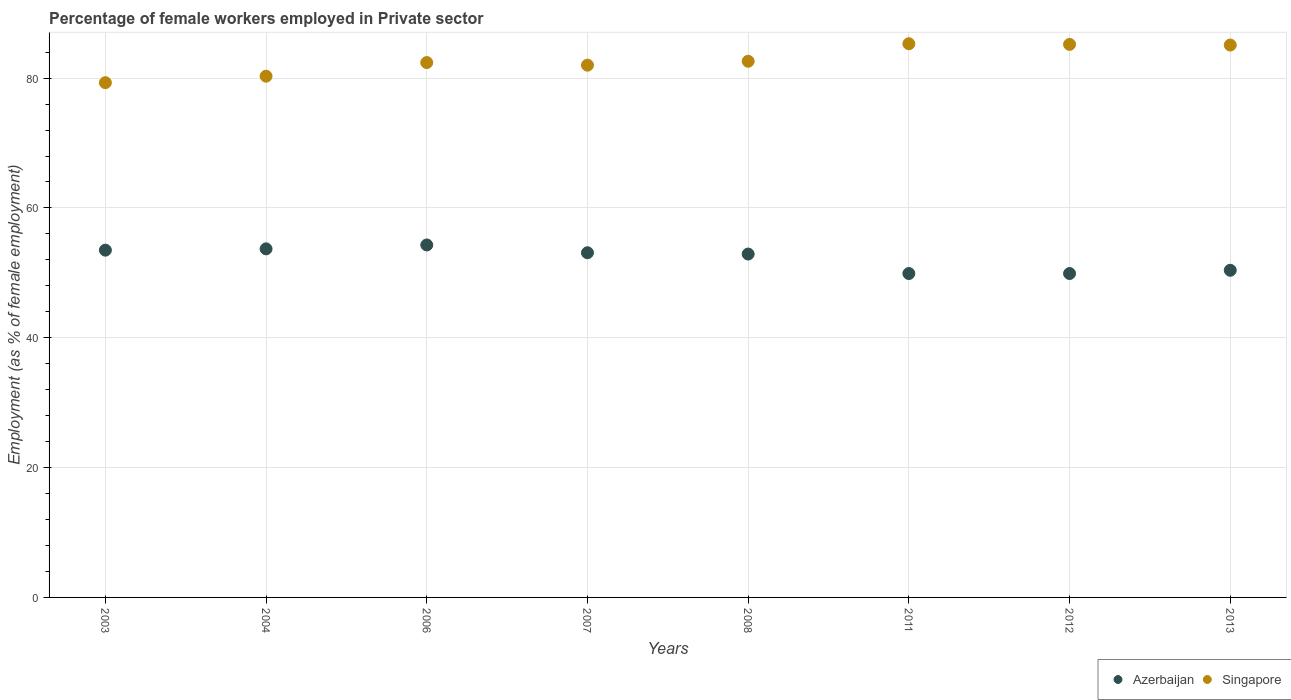How many different coloured dotlines are there?
Your response must be concise. 2. What is the percentage of females employed in Private sector in Singapore in 2007?
Make the answer very short. 82. Across all years, what is the maximum percentage of females employed in Private sector in Azerbaijan?
Give a very brief answer. 54.3. Across all years, what is the minimum percentage of females employed in Private sector in Singapore?
Your answer should be compact. 79.3. What is the total percentage of females employed in Private sector in Azerbaijan in the graph?
Your answer should be compact. 417.7. What is the difference between the percentage of females employed in Private sector in Azerbaijan in 2003 and that in 2006?
Keep it short and to the point. -0.8. What is the difference between the percentage of females employed in Private sector in Azerbaijan in 2011 and the percentage of females employed in Private sector in Singapore in 2012?
Ensure brevity in your answer.  -35.3. What is the average percentage of females employed in Private sector in Azerbaijan per year?
Your answer should be compact. 52.21. In the year 2013, what is the difference between the percentage of females employed in Private sector in Azerbaijan and percentage of females employed in Private sector in Singapore?
Give a very brief answer. -34.7. In how many years, is the percentage of females employed in Private sector in Azerbaijan greater than 12 %?
Make the answer very short. 8. What is the ratio of the percentage of females employed in Private sector in Singapore in 2004 to that in 2013?
Provide a short and direct response. 0.94. Is the difference between the percentage of females employed in Private sector in Azerbaijan in 2003 and 2004 greater than the difference between the percentage of females employed in Private sector in Singapore in 2003 and 2004?
Your answer should be very brief. Yes. What is the difference between the highest and the second highest percentage of females employed in Private sector in Singapore?
Your answer should be compact. 0.1. Is the sum of the percentage of females employed in Private sector in Azerbaijan in 2004 and 2006 greater than the maximum percentage of females employed in Private sector in Singapore across all years?
Provide a short and direct response. Yes. Is the percentage of females employed in Private sector in Azerbaijan strictly greater than the percentage of females employed in Private sector in Singapore over the years?
Offer a terse response. No. How many dotlines are there?
Offer a very short reply. 2. How many years are there in the graph?
Offer a very short reply. 8. What is the difference between two consecutive major ticks on the Y-axis?
Provide a short and direct response. 20. Are the values on the major ticks of Y-axis written in scientific E-notation?
Your answer should be very brief. No. Does the graph contain any zero values?
Your answer should be compact. No. Does the graph contain grids?
Make the answer very short. Yes. Where does the legend appear in the graph?
Your response must be concise. Bottom right. How are the legend labels stacked?
Give a very brief answer. Horizontal. What is the title of the graph?
Keep it short and to the point. Percentage of female workers employed in Private sector. Does "Jamaica" appear as one of the legend labels in the graph?
Ensure brevity in your answer.  No. What is the label or title of the Y-axis?
Offer a very short reply. Employment (as % of female employment). What is the Employment (as % of female employment) of Azerbaijan in 2003?
Keep it short and to the point. 53.5. What is the Employment (as % of female employment) in Singapore in 2003?
Make the answer very short. 79.3. What is the Employment (as % of female employment) of Azerbaijan in 2004?
Your answer should be compact. 53.7. What is the Employment (as % of female employment) in Singapore in 2004?
Your answer should be compact. 80.3. What is the Employment (as % of female employment) in Azerbaijan in 2006?
Your response must be concise. 54.3. What is the Employment (as % of female employment) of Singapore in 2006?
Your response must be concise. 82.4. What is the Employment (as % of female employment) of Azerbaijan in 2007?
Make the answer very short. 53.1. What is the Employment (as % of female employment) in Azerbaijan in 2008?
Offer a terse response. 52.9. What is the Employment (as % of female employment) in Singapore in 2008?
Your answer should be compact. 82.6. What is the Employment (as % of female employment) in Azerbaijan in 2011?
Your response must be concise. 49.9. What is the Employment (as % of female employment) in Singapore in 2011?
Provide a short and direct response. 85.3. What is the Employment (as % of female employment) of Azerbaijan in 2012?
Your answer should be compact. 49.9. What is the Employment (as % of female employment) in Singapore in 2012?
Offer a very short reply. 85.2. What is the Employment (as % of female employment) in Azerbaijan in 2013?
Ensure brevity in your answer.  50.4. What is the Employment (as % of female employment) of Singapore in 2013?
Offer a terse response. 85.1. Across all years, what is the maximum Employment (as % of female employment) of Azerbaijan?
Keep it short and to the point. 54.3. Across all years, what is the maximum Employment (as % of female employment) in Singapore?
Offer a terse response. 85.3. Across all years, what is the minimum Employment (as % of female employment) in Azerbaijan?
Ensure brevity in your answer.  49.9. Across all years, what is the minimum Employment (as % of female employment) of Singapore?
Your answer should be compact. 79.3. What is the total Employment (as % of female employment) in Azerbaijan in the graph?
Provide a short and direct response. 417.7. What is the total Employment (as % of female employment) of Singapore in the graph?
Your response must be concise. 662.2. What is the difference between the Employment (as % of female employment) of Azerbaijan in 2003 and that in 2004?
Make the answer very short. -0.2. What is the difference between the Employment (as % of female employment) in Singapore in 2003 and that in 2004?
Offer a very short reply. -1. What is the difference between the Employment (as % of female employment) in Azerbaijan in 2003 and that in 2007?
Your answer should be compact. 0.4. What is the difference between the Employment (as % of female employment) in Azerbaijan in 2003 and that in 2008?
Make the answer very short. 0.6. What is the difference between the Employment (as % of female employment) in Singapore in 2003 and that in 2008?
Provide a succinct answer. -3.3. What is the difference between the Employment (as % of female employment) of Azerbaijan in 2003 and that in 2011?
Give a very brief answer. 3.6. What is the difference between the Employment (as % of female employment) of Singapore in 2003 and that in 2011?
Provide a short and direct response. -6. What is the difference between the Employment (as % of female employment) of Singapore in 2003 and that in 2012?
Offer a terse response. -5.9. What is the difference between the Employment (as % of female employment) of Azerbaijan in 2003 and that in 2013?
Offer a terse response. 3.1. What is the difference between the Employment (as % of female employment) in Singapore in 2003 and that in 2013?
Ensure brevity in your answer.  -5.8. What is the difference between the Employment (as % of female employment) of Singapore in 2004 and that in 2008?
Provide a succinct answer. -2.3. What is the difference between the Employment (as % of female employment) in Azerbaijan in 2004 and that in 2011?
Provide a succinct answer. 3.8. What is the difference between the Employment (as % of female employment) in Singapore in 2004 and that in 2011?
Provide a short and direct response. -5. What is the difference between the Employment (as % of female employment) in Singapore in 2004 and that in 2012?
Provide a succinct answer. -4.9. What is the difference between the Employment (as % of female employment) in Azerbaijan in 2006 and that in 2007?
Keep it short and to the point. 1.2. What is the difference between the Employment (as % of female employment) in Azerbaijan in 2007 and that in 2008?
Your response must be concise. 0.2. What is the difference between the Employment (as % of female employment) of Singapore in 2007 and that in 2008?
Ensure brevity in your answer.  -0.6. What is the difference between the Employment (as % of female employment) of Singapore in 2007 and that in 2011?
Offer a terse response. -3.3. What is the difference between the Employment (as % of female employment) in Azerbaijan in 2007 and that in 2013?
Offer a terse response. 2.7. What is the difference between the Employment (as % of female employment) in Singapore in 2007 and that in 2013?
Your answer should be compact. -3.1. What is the difference between the Employment (as % of female employment) in Singapore in 2008 and that in 2011?
Your answer should be compact. -2.7. What is the difference between the Employment (as % of female employment) of Azerbaijan in 2008 and that in 2012?
Keep it short and to the point. 3. What is the difference between the Employment (as % of female employment) in Singapore in 2008 and that in 2012?
Your answer should be compact. -2.6. What is the difference between the Employment (as % of female employment) in Azerbaijan in 2008 and that in 2013?
Your response must be concise. 2.5. What is the difference between the Employment (as % of female employment) in Singapore in 2008 and that in 2013?
Provide a succinct answer. -2.5. What is the difference between the Employment (as % of female employment) of Azerbaijan in 2011 and that in 2012?
Provide a succinct answer. 0. What is the difference between the Employment (as % of female employment) of Singapore in 2011 and that in 2012?
Your answer should be very brief. 0.1. What is the difference between the Employment (as % of female employment) in Azerbaijan in 2011 and that in 2013?
Your response must be concise. -0.5. What is the difference between the Employment (as % of female employment) of Singapore in 2011 and that in 2013?
Offer a very short reply. 0.2. What is the difference between the Employment (as % of female employment) in Singapore in 2012 and that in 2013?
Your answer should be compact. 0.1. What is the difference between the Employment (as % of female employment) of Azerbaijan in 2003 and the Employment (as % of female employment) of Singapore in 2004?
Offer a very short reply. -26.8. What is the difference between the Employment (as % of female employment) in Azerbaijan in 2003 and the Employment (as % of female employment) in Singapore in 2006?
Your response must be concise. -28.9. What is the difference between the Employment (as % of female employment) of Azerbaijan in 2003 and the Employment (as % of female employment) of Singapore in 2007?
Keep it short and to the point. -28.5. What is the difference between the Employment (as % of female employment) in Azerbaijan in 2003 and the Employment (as % of female employment) in Singapore in 2008?
Give a very brief answer. -29.1. What is the difference between the Employment (as % of female employment) in Azerbaijan in 2003 and the Employment (as % of female employment) in Singapore in 2011?
Make the answer very short. -31.8. What is the difference between the Employment (as % of female employment) of Azerbaijan in 2003 and the Employment (as % of female employment) of Singapore in 2012?
Offer a very short reply. -31.7. What is the difference between the Employment (as % of female employment) of Azerbaijan in 2003 and the Employment (as % of female employment) of Singapore in 2013?
Your answer should be compact. -31.6. What is the difference between the Employment (as % of female employment) in Azerbaijan in 2004 and the Employment (as % of female employment) in Singapore in 2006?
Offer a terse response. -28.7. What is the difference between the Employment (as % of female employment) of Azerbaijan in 2004 and the Employment (as % of female employment) of Singapore in 2007?
Your answer should be compact. -28.3. What is the difference between the Employment (as % of female employment) in Azerbaijan in 2004 and the Employment (as % of female employment) in Singapore in 2008?
Your answer should be very brief. -28.9. What is the difference between the Employment (as % of female employment) of Azerbaijan in 2004 and the Employment (as % of female employment) of Singapore in 2011?
Provide a short and direct response. -31.6. What is the difference between the Employment (as % of female employment) in Azerbaijan in 2004 and the Employment (as % of female employment) in Singapore in 2012?
Keep it short and to the point. -31.5. What is the difference between the Employment (as % of female employment) in Azerbaijan in 2004 and the Employment (as % of female employment) in Singapore in 2013?
Offer a very short reply. -31.4. What is the difference between the Employment (as % of female employment) in Azerbaijan in 2006 and the Employment (as % of female employment) in Singapore in 2007?
Your response must be concise. -27.7. What is the difference between the Employment (as % of female employment) of Azerbaijan in 2006 and the Employment (as % of female employment) of Singapore in 2008?
Offer a terse response. -28.3. What is the difference between the Employment (as % of female employment) in Azerbaijan in 2006 and the Employment (as % of female employment) in Singapore in 2011?
Your response must be concise. -31. What is the difference between the Employment (as % of female employment) in Azerbaijan in 2006 and the Employment (as % of female employment) in Singapore in 2012?
Keep it short and to the point. -30.9. What is the difference between the Employment (as % of female employment) in Azerbaijan in 2006 and the Employment (as % of female employment) in Singapore in 2013?
Your response must be concise. -30.8. What is the difference between the Employment (as % of female employment) in Azerbaijan in 2007 and the Employment (as % of female employment) in Singapore in 2008?
Provide a short and direct response. -29.5. What is the difference between the Employment (as % of female employment) of Azerbaijan in 2007 and the Employment (as % of female employment) of Singapore in 2011?
Ensure brevity in your answer.  -32.2. What is the difference between the Employment (as % of female employment) of Azerbaijan in 2007 and the Employment (as % of female employment) of Singapore in 2012?
Keep it short and to the point. -32.1. What is the difference between the Employment (as % of female employment) of Azerbaijan in 2007 and the Employment (as % of female employment) of Singapore in 2013?
Your answer should be compact. -32. What is the difference between the Employment (as % of female employment) of Azerbaijan in 2008 and the Employment (as % of female employment) of Singapore in 2011?
Offer a terse response. -32.4. What is the difference between the Employment (as % of female employment) of Azerbaijan in 2008 and the Employment (as % of female employment) of Singapore in 2012?
Make the answer very short. -32.3. What is the difference between the Employment (as % of female employment) of Azerbaijan in 2008 and the Employment (as % of female employment) of Singapore in 2013?
Your answer should be compact. -32.2. What is the difference between the Employment (as % of female employment) of Azerbaijan in 2011 and the Employment (as % of female employment) of Singapore in 2012?
Ensure brevity in your answer.  -35.3. What is the difference between the Employment (as % of female employment) in Azerbaijan in 2011 and the Employment (as % of female employment) in Singapore in 2013?
Give a very brief answer. -35.2. What is the difference between the Employment (as % of female employment) in Azerbaijan in 2012 and the Employment (as % of female employment) in Singapore in 2013?
Your answer should be very brief. -35.2. What is the average Employment (as % of female employment) in Azerbaijan per year?
Provide a short and direct response. 52.21. What is the average Employment (as % of female employment) of Singapore per year?
Offer a very short reply. 82.78. In the year 2003, what is the difference between the Employment (as % of female employment) in Azerbaijan and Employment (as % of female employment) in Singapore?
Offer a terse response. -25.8. In the year 2004, what is the difference between the Employment (as % of female employment) in Azerbaijan and Employment (as % of female employment) in Singapore?
Ensure brevity in your answer.  -26.6. In the year 2006, what is the difference between the Employment (as % of female employment) in Azerbaijan and Employment (as % of female employment) in Singapore?
Provide a succinct answer. -28.1. In the year 2007, what is the difference between the Employment (as % of female employment) of Azerbaijan and Employment (as % of female employment) of Singapore?
Ensure brevity in your answer.  -28.9. In the year 2008, what is the difference between the Employment (as % of female employment) of Azerbaijan and Employment (as % of female employment) of Singapore?
Your answer should be very brief. -29.7. In the year 2011, what is the difference between the Employment (as % of female employment) of Azerbaijan and Employment (as % of female employment) of Singapore?
Give a very brief answer. -35.4. In the year 2012, what is the difference between the Employment (as % of female employment) in Azerbaijan and Employment (as % of female employment) in Singapore?
Keep it short and to the point. -35.3. In the year 2013, what is the difference between the Employment (as % of female employment) in Azerbaijan and Employment (as % of female employment) in Singapore?
Your answer should be compact. -34.7. What is the ratio of the Employment (as % of female employment) of Azerbaijan in 2003 to that in 2004?
Ensure brevity in your answer.  1. What is the ratio of the Employment (as % of female employment) in Singapore in 2003 to that in 2004?
Ensure brevity in your answer.  0.99. What is the ratio of the Employment (as % of female employment) of Singapore in 2003 to that in 2006?
Your answer should be compact. 0.96. What is the ratio of the Employment (as % of female employment) of Azerbaijan in 2003 to that in 2007?
Provide a succinct answer. 1.01. What is the ratio of the Employment (as % of female employment) of Singapore in 2003 to that in 2007?
Provide a succinct answer. 0.97. What is the ratio of the Employment (as % of female employment) in Azerbaijan in 2003 to that in 2008?
Offer a terse response. 1.01. What is the ratio of the Employment (as % of female employment) of Azerbaijan in 2003 to that in 2011?
Your answer should be compact. 1.07. What is the ratio of the Employment (as % of female employment) of Singapore in 2003 to that in 2011?
Offer a very short reply. 0.93. What is the ratio of the Employment (as % of female employment) in Azerbaijan in 2003 to that in 2012?
Make the answer very short. 1.07. What is the ratio of the Employment (as % of female employment) of Singapore in 2003 to that in 2012?
Offer a very short reply. 0.93. What is the ratio of the Employment (as % of female employment) of Azerbaijan in 2003 to that in 2013?
Offer a very short reply. 1.06. What is the ratio of the Employment (as % of female employment) of Singapore in 2003 to that in 2013?
Ensure brevity in your answer.  0.93. What is the ratio of the Employment (as % of female employment) in Singapore in 2004 to that in 2006?
Your answer should be very brief. 0.97. What is the ratio of the Employment (as % of female employment) of Azerbaijan in 2004 to that in 2007?
Ensure brevity in your answer.  1.01. What is the ratio of the Employment (as % of female employment) in Singapore in 2004 to that in 2007?
Your answer should be compact. 0.98. What is the ratio of the Employment (as % of female employment) in Azerbaijan in 2004 to that in 2008?
Give a very brief answer. 1.02. What is the ratio of the Employment (as % of female employment) of Singapore in 2004 to that in 2008?
Your answer should be very brief. 0.97. What is the ratio of the Employment (as % of female employment) of Azerbaijan in 2004 to that in 2011?
Provide a short and direct response. 1.08. What is the ratio of the Employment (as % of female employment) of Singapore in 2004 to that in 2011?
Your response must be concise. 0.94. What is the ratio of the Employment (as % of female employment) of Azerbaijan in 2004 to that in 2012?
Make the answer very short. 1.08. What is the ratio of the Employment (as % of female employment) of Singapore in 2004 to that in 2012?
Provide a short and direct response. 0.94. What is the ratio of the Employment (as % of female employment) in Azerbaijan in 2004 to that in 2013?
Give a very brief answer. 1.07. What is the ratio of the Employment (as % of female employment) of Singapore in 2004 to that in 2013?
Keep it short and to the point. 0.94. What is the ratio of the Employment (as % of female employment) in Azerbaijan in 2006 to that in 2007?
Offer a terse response. 1.02. What is the ratio of the Employment (as % of female employment) of Azerbaijan in 2006 to that in 2008?
Make the answer very short. 1.03. What is the ratio of the Employment (as % of female employment) in Singapore in 2006 to that in 2008?
Ensure brevity in your answer.  1. What is the ratio of the Employment (as % of female employment) of Azerbaijan in 2006 to that in 2011?
Your answer should be compact. 1.09. What is the ratio of the Employment (as % of female employment) in Azerbaijan in 2006 to that in 2012?
Your response must be concise. 1.09. What is the ratio of the Employment (as % of female employment) of Singapore in 2006 to that in 2012?
Your answer should be compact. 0.97. What is the ratio of the Employment (as % of female employment) of Azerbaijan in 2006 to that in 2013?
Your answer should be very brief. 1.08. What is the ratio of the Employment (as % of female employment) of Singapore in 2006 to that in 2013?
Your answer should be compact. 0.97. What is the ratio of the Employment (as % of female employment) in Azerbaijan in 2007 to that in 2011?
Ensure brevity in your answer.  1.06. What is the ratio of the Employment (as % of female employment) in Singapore in 2007 to that in 2011?
Your answer should be compact. 0.96. What is the ratio of the Employment (as % of female employment) in Azerbaijan in 2007 to that in 2012?
Keep it short and to the point. 1.06. What is the ratio of the Employment (as % of female employment) of Singapore in 2007 to that in 2012?
Your answer should be very brief. 0.96. What is the ratio of the Employment (as % of female employment) of Azerbaijan in 2007 to that in 2013?
Your response must be concise. 1.05. What is the ratio of the Employment (as % of female employment) of Singapore in 2007 to that in 2013?
Offer a very short reply. 0.96. What is the ratio of the Employment (as % of female employment) in Azerbaijan in 2008 to that in 2011?
Keep it short and to the point. 1.06. What is the ratio of the Employment (as % of female employment) of Singapore in 2008 to that in 2011?
Your answer should be very brief. 0.97. What is the ratio of the Employment (as % of female employment) in Azerbaijan in 2008 to that in 2012?
Your answer should be very brief. 1.06. What is the ratio of the Employment (as % of female employment) in Singapore in 2008 to that in 2012?
Keep it short and to the point. 0.97. What is the ratio of the Employment (as % of female employment) in Azerbaijan in 2008 to that in 2013?
Keep it short and to the point. 1.05. What is the ratio of the Employment (as % of female employment) in Singapore in 2008 to that in 2013?
Your response must be concise. 0.97. What is the ratio of the Employment (as % of female employment) of Azerbaijan in 2011 to that in 2012?
Your answer should be very brief. 1. What is the ratio of the Employment (as % of female employment) of Singapore in 2011 to that in 2013?
Your response must be concise. 1. What is the ratio of the Employment (as % of female employment) in Azerbaijan in 2012 to that in 2013?
Your response must be concise. 0.99. What is the difference between the highest and the second highest Employment (as % of female employment) of Azerbaijan?
Ensure brevity in your answer.  0.6. What is the difference between the highest and the second highest Employment (as % of female employment) in Singapore?
Make the answer very short. 0.1. What is the difference between the highest and the lowest Employment (as % of female employment) of Azerbaijan?
Your answer should be very brief. 4.4. 